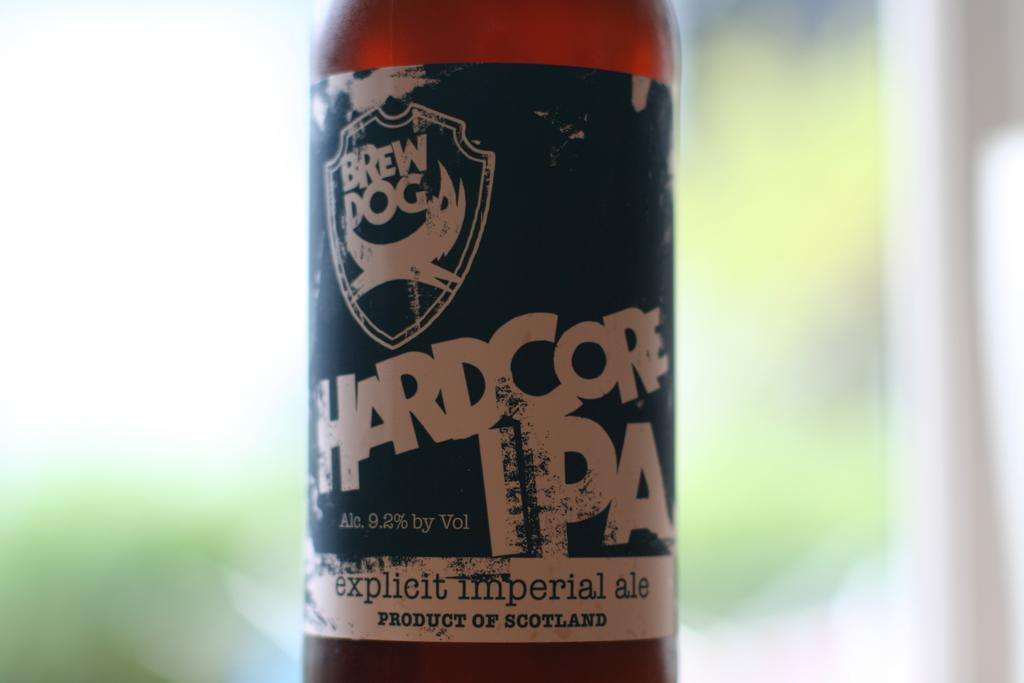What object is located at the middle of the image? There is a bottle in the image, and it is at the middle. What can be found on the bottle? The bottle has a label with text on it. How would you describe the background of the image? The background of the image is blurry. What type of coal is visible in the image? There is no coal present in the image. How much honey can be seen dripping from the bottle in the image? There is no honey present in the image, and the bottle has a label with text on it, not honey. 